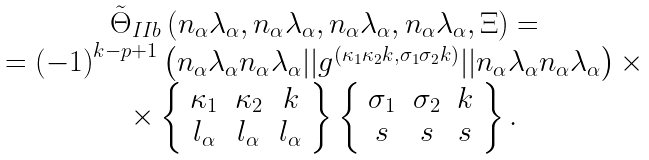Convert formula to latex. <formula><loc_0><loc_0><loc_500><loc_500>\begin{array} [ b ] { c } \tilde { \Theta } _ { I I b } \left ( n _ { \alpha } \lambda _ { \alpha } , n _ { \alpha } \lambda _ { \alpha } , n _ { \alpha } \lambda _ { \alpha } , n _ { \alpha } \lambda _ { \alpha } , \Xi \right ) = \\ = \left ( - 1 \right ) ^ { k - p + 1 } \left ( n _ { \alpha } \lambda _ { \alpha } n _ { \alpha } \lambda _ { \alpha } | | g ^ { \left ( \kappa _ { 1 } \kappa _ { 2 } k , \sigma _ { 1 } \sigma _ { 2 } k \right ) } | | n _ { \alpha } \lambda _ { \alpha } n _ { \alpha } \lambda _ { \alpha } \right ) \times \\ \times \left \{ \begin{array} { c c c } \kappa _ { 1 } & \kappa _ { 2 } & k \\ l _ { \alpha } & l _ { \alpha } & l _ { \alpha } \end{array} \right \} \left \{ \begin{array} { c c c } \sigma _ { 1 } & \sigma _ { 2 } & k \\ s & s & s \end{array} \right \} . \end{array}</formula> 